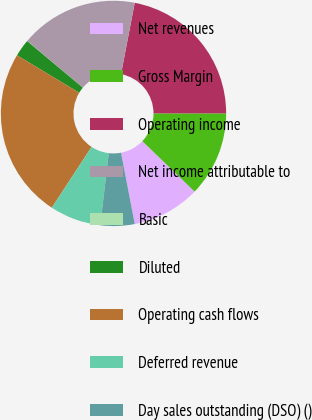Convert chart to OTSL. <chart><loc_0><loc_0><loc_500><loc_500><pie_chart><fcel>Net revenues<fcel>Gross Margin<fcel>Operating income<fcel>Net income attributable to<fcel>Basic<fcel>Diluted<fcel>Operating cash flows<fcel>Deferred revenue<fcel>Day sales outstanding (DSO) ()<nl><fcel>9.77%<fcel>12.21%<fcel>21.98%<fcel>16.89%<fcel>0.03%<fcel>2.47%<fcel>24.41%<fcel>7.34%<fcel>4.9%<nl></chart> 